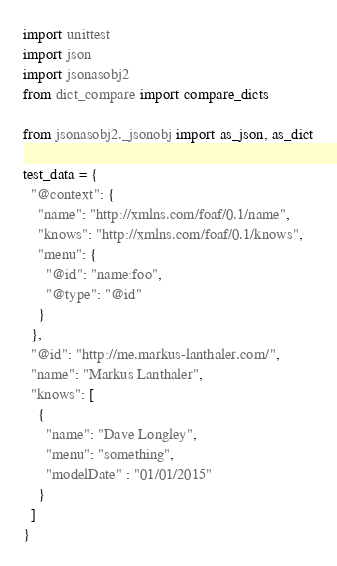<code> <loc_0><loc_0><loc_500><loc_500><_Python_>import unittest
import json
import jsonasobj2
from dict_compare import compare_dicts

from jsonasobj2._jsonobj import as_json, as_dict

test_data = {
  "@context": {
    "name": "http://xmlns.com/foaf/0.1/name",
    "knows": "http://xmlns.com/foaf/0.1/knows",
    "menu": {
      "@id": "name:foo",
      "@type": "@id"
    }
  },
  "@id": "http://me.markus-lanthaler.com/",
  "name": "Markus Lanthaler",
  "knows": [
    {
      "name": "Dave Longley",
      "menu": "something",
      "modelDate" : "01/01/2015"
    }
  ]
}</code> 